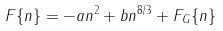Convert formula to latex. <formula><loc_0><loc_0><loc_500><loc_500>F \{ n \} = - a n ^ { 2 } + b n ^ { 8 / 3 } + F _ { G } \{ n \}</formula> 